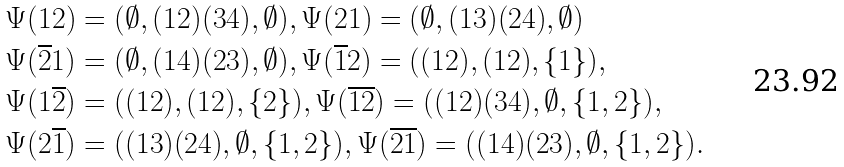Convert formula to latex. <formula><loc_0><loc_0><loc_500><loc_500>\Psi ( 1 2 ) & = ( \emptyset , ( 1 2 ) ( 3 4 ) , \emptyset ) , \Psi ( 2 1 ) = ( \emptyset , ( 1 3 ) ( 2 4 ) , \emptyset ) \\ \Psi ( \overline { 2 } 1 ) & = ( \emptyset , ( 1 4 ) ( 2 3 ) , \emptyset ) , \Psi ( \overline { 1 } { 2 } ) = ( ( 1 2 ) , ( 1 2 ) , \{ 1 \} ) , \\ \Psi ( 1 \overline { 2 } ) & = ( ( 1 2 ) , ( 1 2 ) , \{ 2 \} ) , \Psi ( \overline { 1 } \overline { 2 } ) = ( ( 1 2 ) ( 3 4 ) , \emptyset , \{ 1 , 2 \} ) , \\ \Psi ( 2 \overline { 1 } ) & = ( ( 1 3 ) ( 2 4 ) , \emptyset , \{ 1 , 2 \} ) , \Psi ( \overline { 2 } \overline { 1 } ) = ( ( 1 4 ) ( 2 3 ) , \emptyset , \{ 1 , 2 \} ) .</formula> 